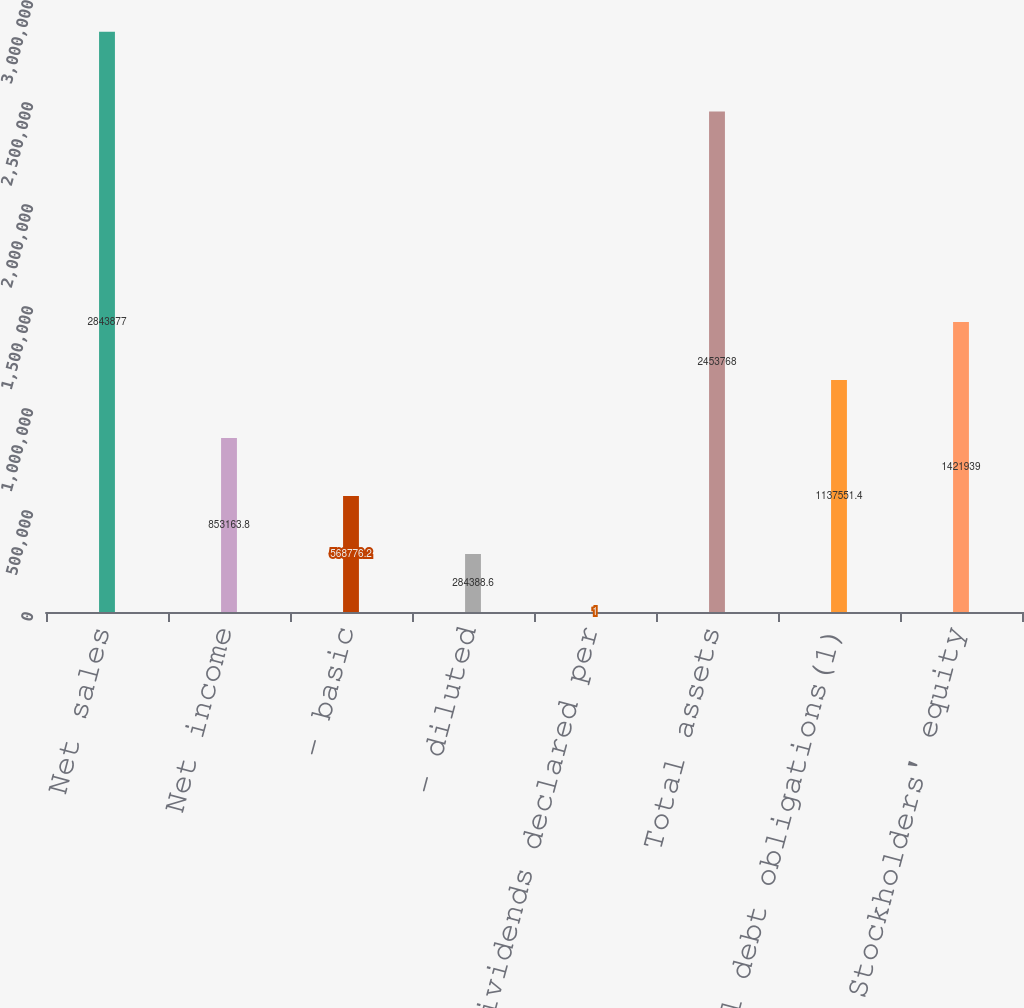<chart> <loc_0><loc_0><loc_500><loc_500><bar_chart><fcel>Net sales<fcel>Net income<fcel>- basic<fcel>- diluted<fcel>Cash dividends declared per<fcel>Total assets<fcel>Total debt obligations(1)<fcel>Stockholders' equity<nl><fcel>2.84388e+06<fcel>853164<fcel>568776<fcel>284389<fcel>1<fcel>2.45377e+06<fcel>1.13755e+06<fcel>1.42194e+06<nl></chart> 